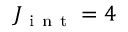Convert formula to latex. <formula><loc_0><loc_0><loc_500><loc_500>J _ { i n t } = 4</formula> 